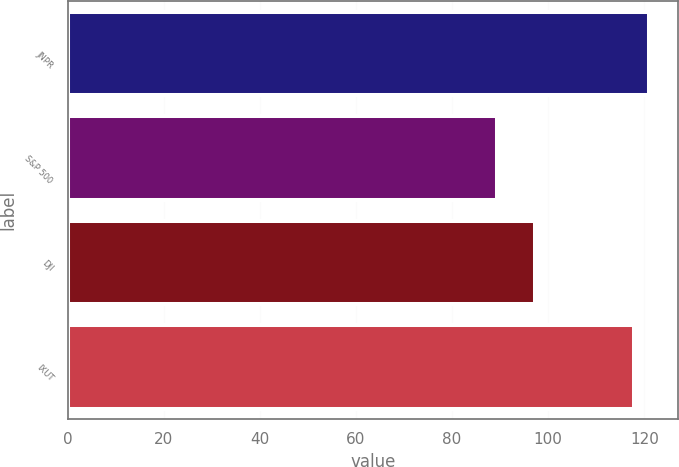Convert chart to OTSL. <chart><loc_0><loc_0><loc_500><loc_500><bar_chart><fcel>JNPR<fcel>S&P 500<fcel>DJI<fcel>IXUT<nl><fcel>120.92<fcel>89.33<fcel>97.3<fcel>117.89<nl></chart> 